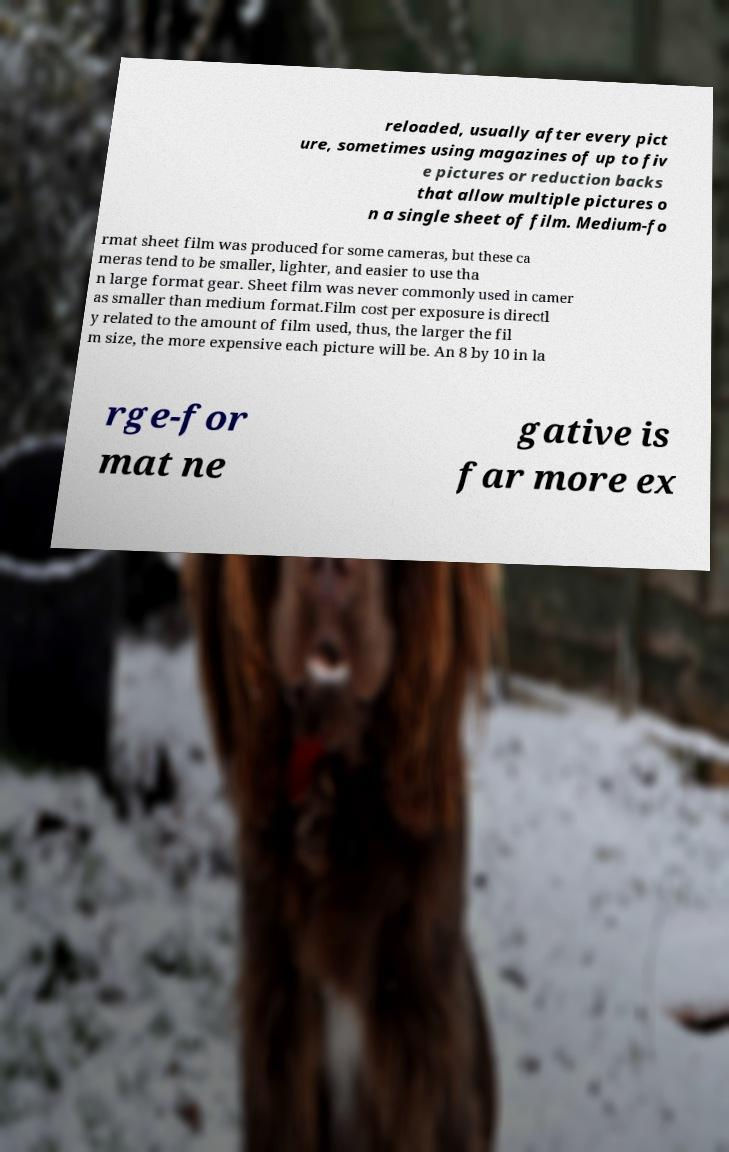For documentation purposes, I need the text within this image transcribed. Could you provide that? reloaded, usually after every pict ure, sometimes using magazines of up to fiv e pictures or reduction backs that allow multiple pictures o n a single sheet of film. Medium-fo rmat sheet film was produced for some cameras, but these ca meras tend to be smaller, lighter, and easier to use tha n large format gear. Sheet film was never commonly used in camer as smaller than medium format.Film cost per exposure is directl y related to the amount of film used, thus, the larger the fil m size, the more expensive each picture will be. An 8 by 10 in la rge-for mat ne gative is far more ex 